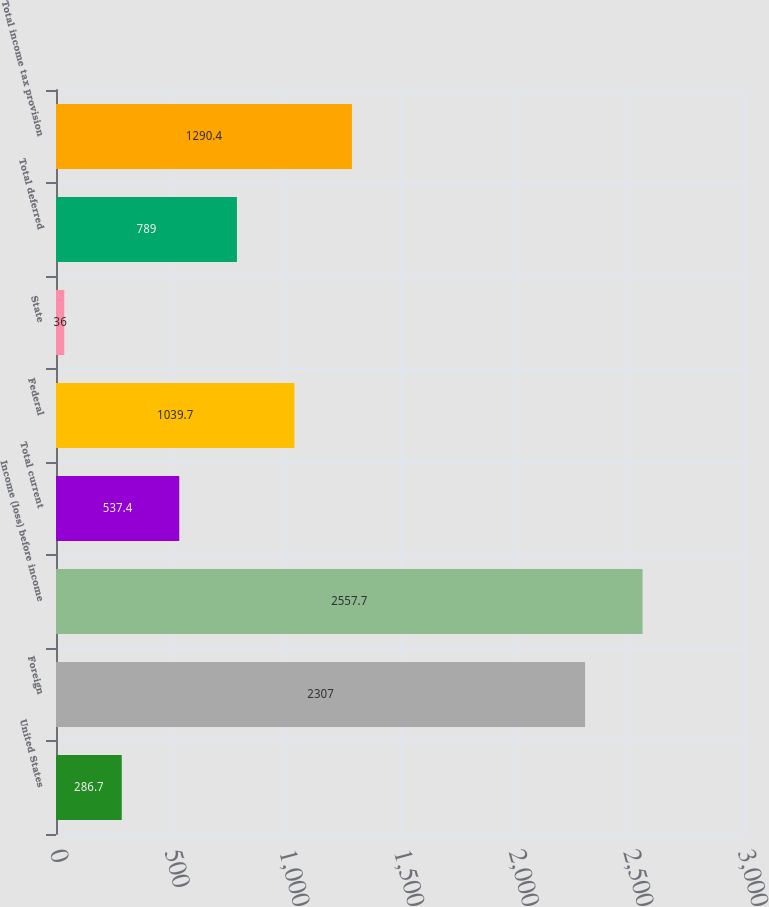Convert chart. <chart><loc_0><loc_0><loc_500><loc_500><bar_chart><fcel>United States<fcel>Foreign<fcel>Income (loss) before income<fcel>Total current<fcel>Federal<fcel>State<fcel>Total deferred<fcel>Total income tax provision<nl><fcel>286.7<fcel>2307<fcel>2557.7<fcel>537.4<fcel>1039.7<fcel>36<fcel>789<fcel>1290.4<nl></chart> 